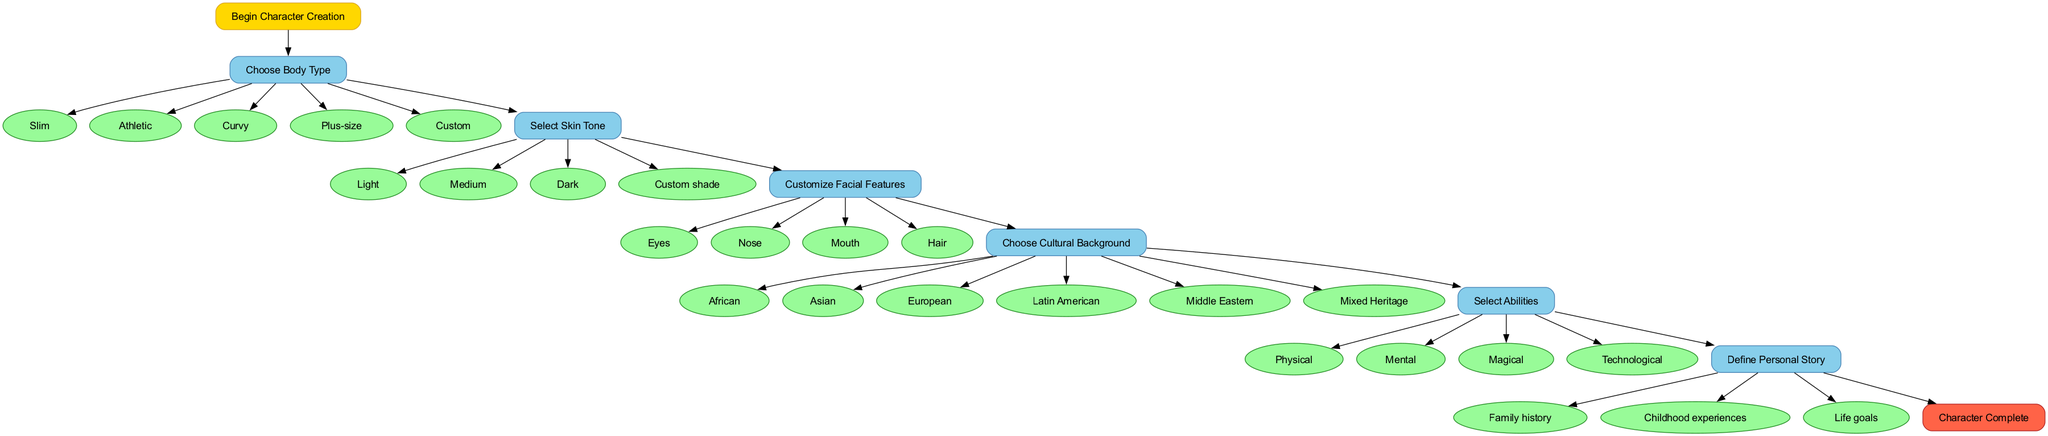What is the first step in the character creation process? The first node in the flow chart is labeled "Choose Body Type," which is connected directly from the "Start" node. This indicates that this step is the initial action taken in the character creation process.
Answer: Choose Body Type How many body type options are available? From the "Choose Body Type" step, there are five listed options: Slim, Athletic, Curvy, Plus-size, and Custom. Therefore, counting these options gives a total of five.
Answer: 5 What is the last step before completing the character? The last step before reaching the end node "Character Complete" is "Define Personal Story." It is the final action players need to take in the flow, connected from the second to last step in the flow chart.
Answer: Define Personal Story Name one of the cultural backgrounds players can choose. Within the "Choose Cultural Background" step, one of the available options is "African." This is explicitly listed among the multiple options provided under that step.
Answer: African Which category has four options for abilities? The "Select Abilities" step lists four distinct options: Physical, Mental, Magical, and Technological. By counting these options, it is evident that this category contains four choices available for players.
Answer: 4 What connects the "Select Skin Tone" step and the "Customize Facial Features" step? The connection from "Select Skin Tone" to "Customize Facial Features" is indicated by a directed edge that shows the flow between these two steps in the character creation process. This means players progress sequentially from selecting skin tone to customizing facial features.
Answer: Edge/connection How many options are presented for customizing facial features? Under the "Customize Facial Features" step, there are four options listed: Eyes, Nose, Mouth, and Hair. Counting these reveals that there are four options available for players to customize their character's facial features.
Answer: 4 What is indicated at the end of the flow chart? The end of the diagram is marked by the node labeled "Character Complete," which signifies the conclusion of the character creation process after players have gone through all necessary steps and made their selections.
Answer: Character Complete How many diverse cultural backgrounds can players choose from? The "Choose Cultural Background" step lists a total of six options: African, Asian, European, Latin American, Middle Eastern, and Mixed Heritage. This totals to six diverse backgrounds available for players.
Answer: 6 